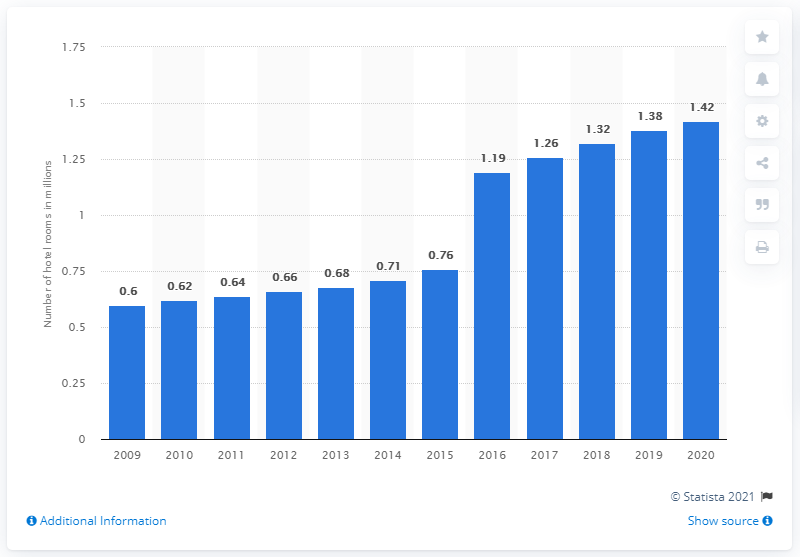List a handful of essential elements in this visual. In 2020, Marriott International, Inc. had approximately 1.42 million hotel rooms. 